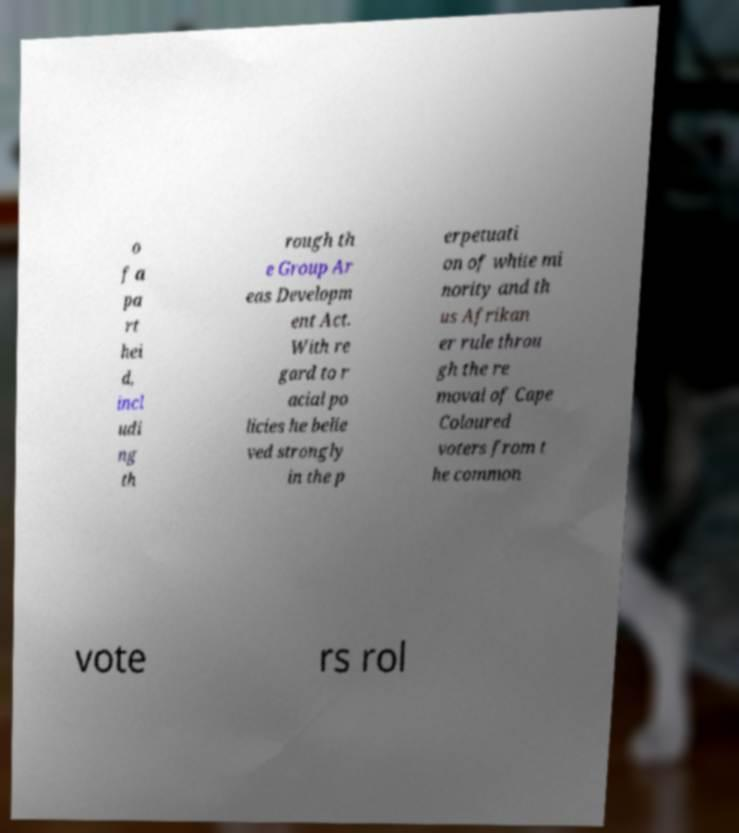Could you assist in decoding the text presented in this image and type it out clearly? o f a pa rt hei d, incl udi ng th rough th e Group Ar eas Developm ent Act. With re gard to r acial po licies he belie ved strongly in the p erpetuati on of white mi nority and th us Afrikan er rule throu gh the re moval of Cape Coloured voters from t he common vote rs rol 